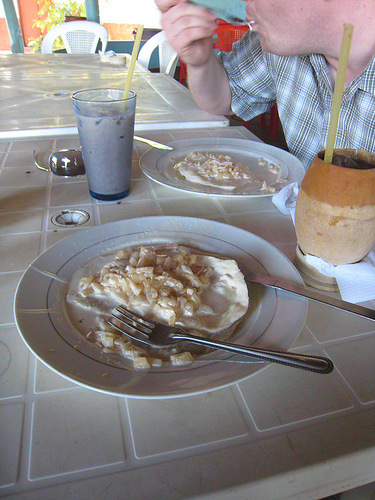<image>
Is the plate on the table? Yes. Looking at the image, I can see the plate is positioned on top of the table, with the table providing support. 